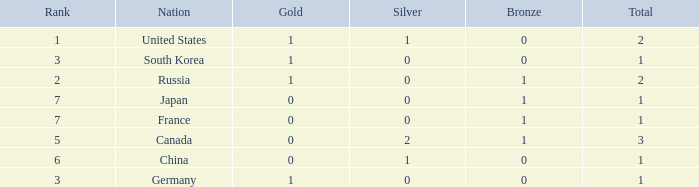Which Bronze has a Rank of 3, and a Silver larger than 0? None. 